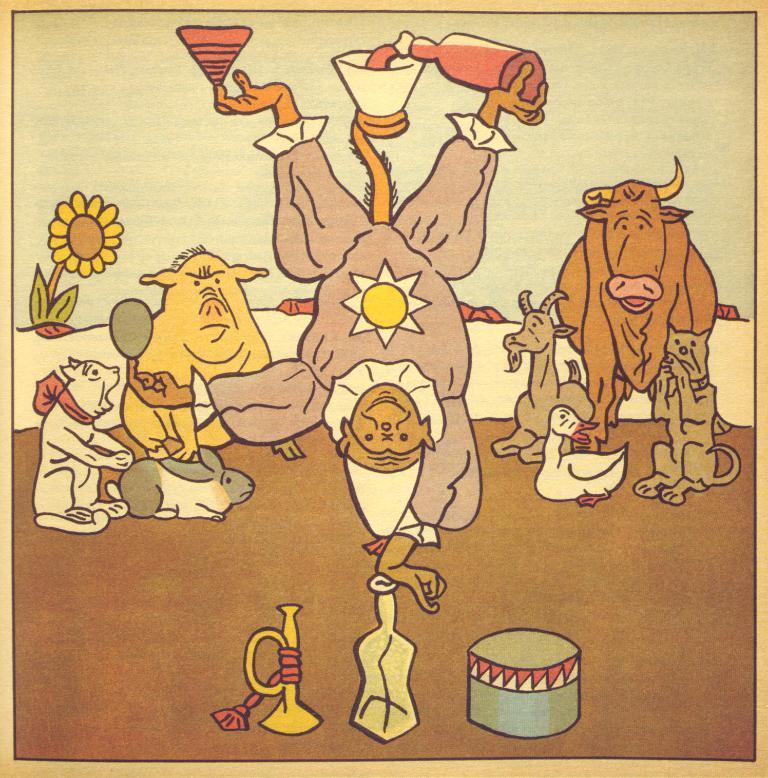Describe this image in one or two sentences. In this image there is a painting of a person, animals, flower and few other objects on a paper. 